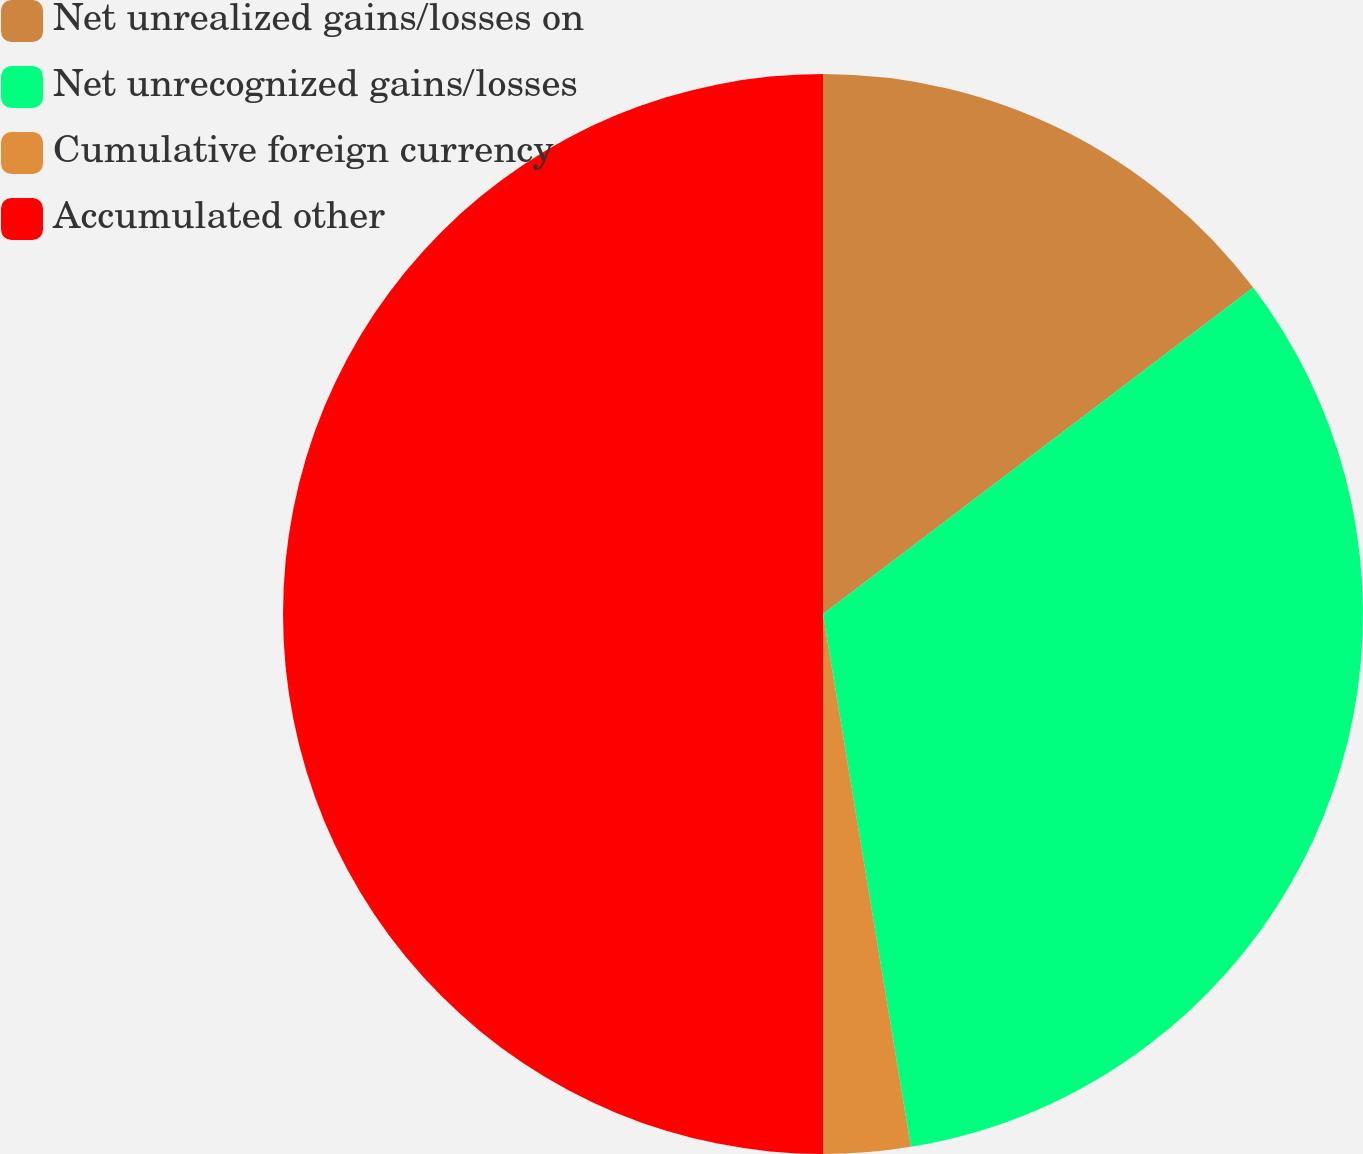Convert chart to OTSL. <chart><loc_0><loc_0><loc_500><loc_500><pie_chart><fcel>Net unrealized gains/losses on<fcel>Net unrecognized gains/losses<fcel>Cumulative foreign currency<fcel>Accumulated other<nl><fcel>14.67%<fcel>32.73%<fcel>2.6%<fcel>50.0%<nl></chart> 